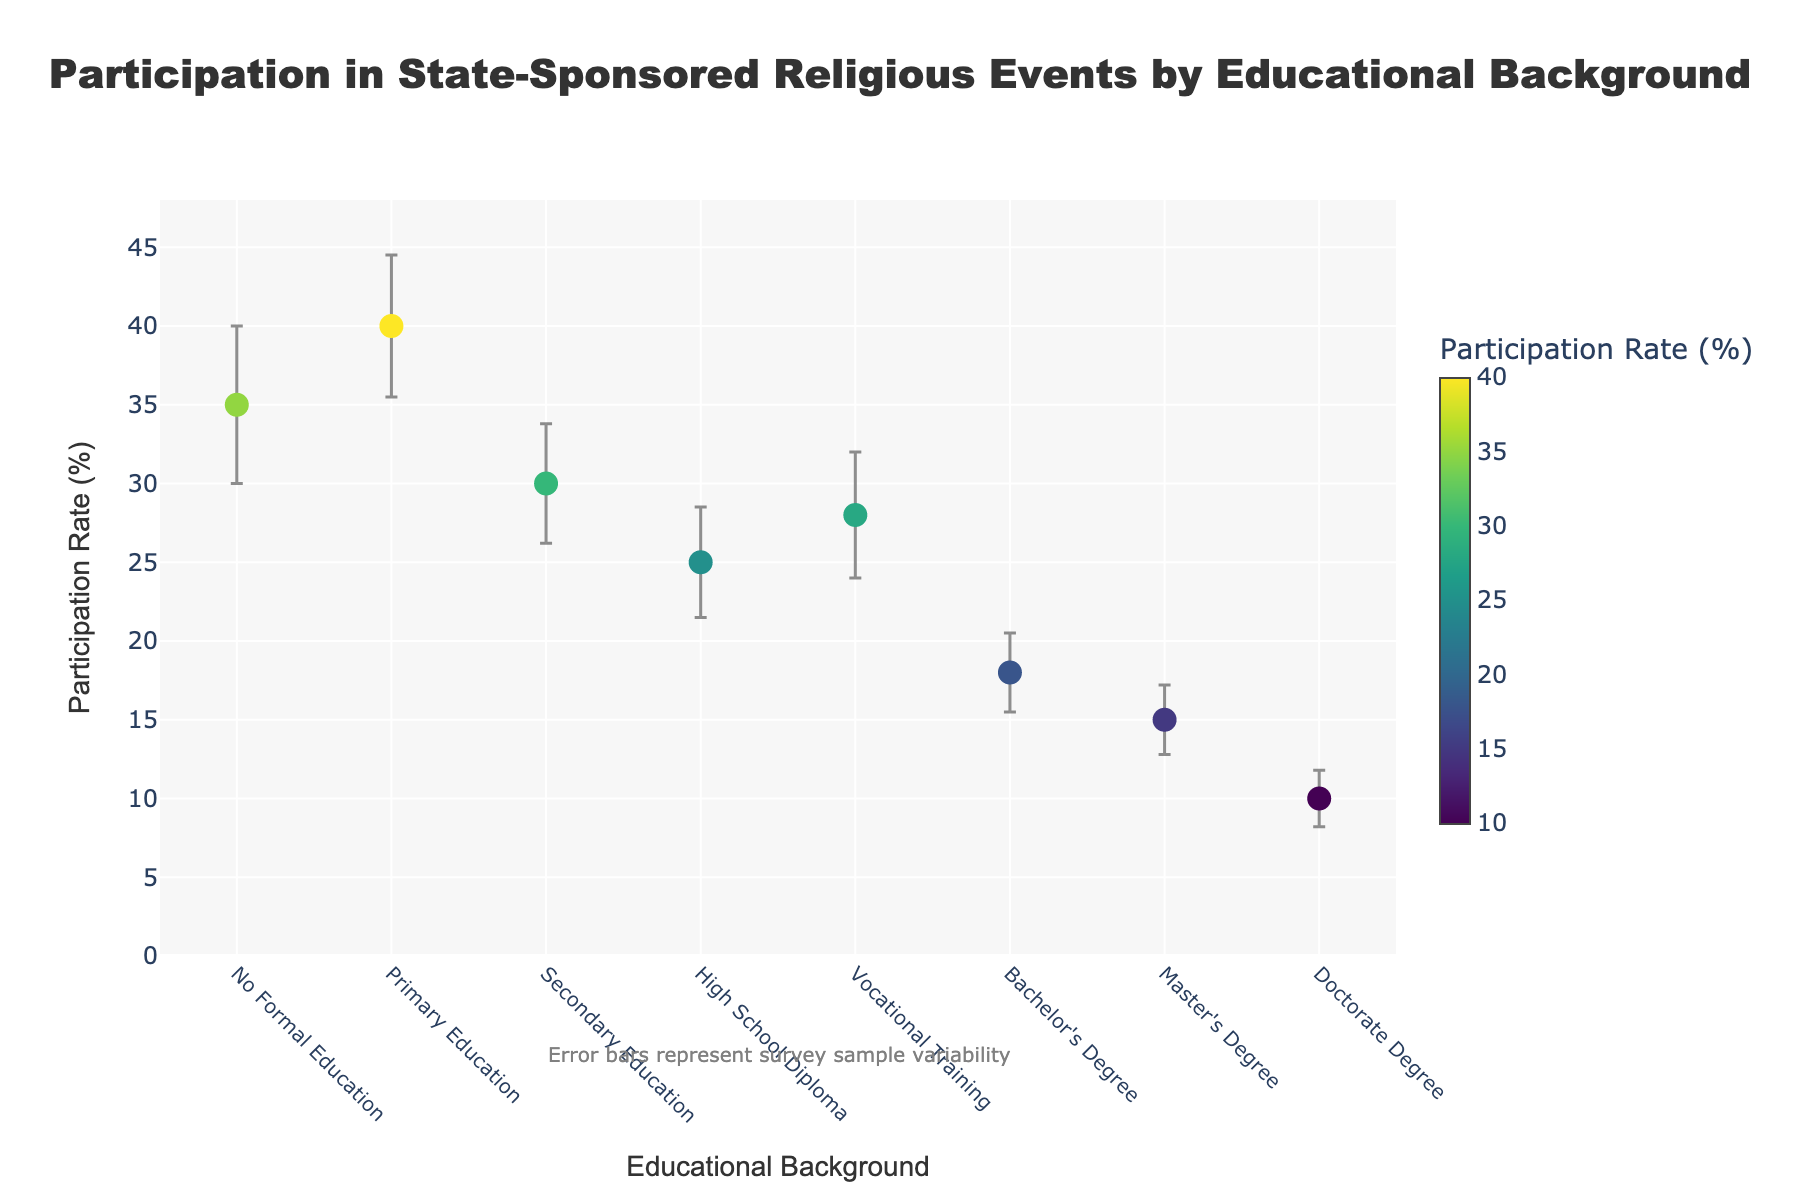What is the title of the plot? The title is displayed at the top center of the plot.
Answer: Participation in State-Sponsored Religious Events by Educational Background What is the participation rate for people with a Bachelor's Degree? Locate the data point corresponding to "Bachelor's Degree" on the x-axis, then check its y-value.
Answer: 18% Which education group shows the highest participation rate? Identify the data point with the highest value on the y-axis and check its corresponding category on the x-axis.
Answer: No Formal Education What is the difference in participation rates between individuals with Primary Education and those with Secondary Education? Subtract the participation rate of people with Secondary Education from that of people with Primary Education.
Answer: 10% Which educational background has the smallest error bar? Locate the data points with the shortest vertical lines (error bars), and identify the corresponding category on the x-axis.
Answer: Doctorate Degree What is the range of participation rates shown in the plot? Identify the minimum and maximum y-values among the data points. The range is the difference between these two values.
Answer: 10% to 35% How does the participation rate change with increasing educational background? Observe the trend of data points as you move from "No Formal Education" to "Doctorate Degree" on the x-axis.
Answer: Generally decreases What is the median participation rate among all educational backgrounds? Arrange the participation rates in ascending order, then find the middle value.
Answer: 25% Compare the participation rates of individuals with a High School Diploma and Vocational Training. Which is higher and by how much? Locate the data points for both categories and compare their y-values. Subtract the smaller value from the larger one.
Answer: High School Diploma by 3% Are there any error bars that overlap for different educational backgrounds? Visually inspect the range of the error bars for each data point and check if the ranges intersect.
Answer: Primary Education and Secondary Education 